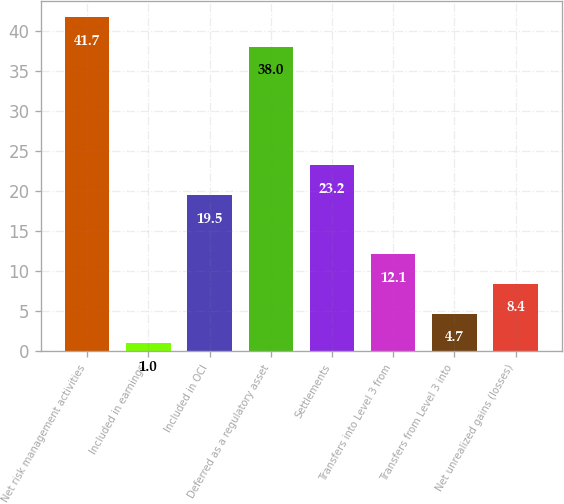Convert chart to OTSL. <chart><loc_0><loc_0><loc_500><loc_500><bar_chart><fcel>Net risk management activities<fcel>Included in earnings<fcel>Included in OCI<fcel>Deferred as a regulatory asset<fcel>Settlements<fcel>Transfers into Level 3 from<fcel>Transfers from Level 3 into<fcel>Net unrealized gains (losses)<nl><fcel>41.7<fcel>1<fcel>19.5<fcel>38<fcel>23.2<fcel>12.1<fcel>4.7<fcel>8.4<nl></chart> 